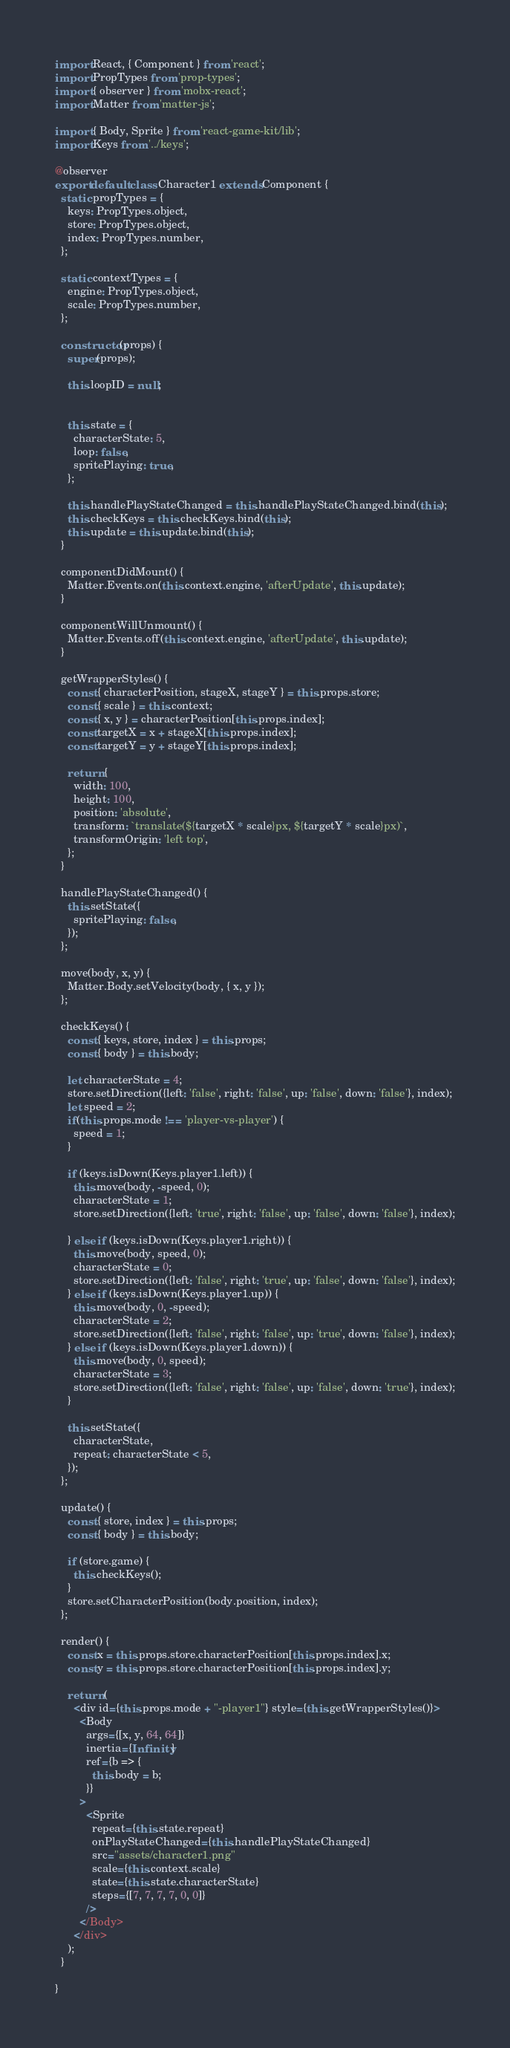Convert code to text. <code><loc_0><loc_0><loc_500><loc_500><_JavaScript_>import React, { Component } from 'react';
import PropTypes from 'prop-types';
import { observer } from 'mobx-react';
import Matter from 'matter-js';

import { Body, Sprite } from 'react-game-kit/lib';
import Keys from '../keys';

@observer
export default class Character1 extends Component {
  static propTypes = {
    keys: PropTypes.object,
    store: PropTypes.object,
    index: PropTypes.number,
  };

  static contextTypes = {
    engine: PropTypes.object,
    scale: PropTypes.number,
  };

  constructor(props) {
    super(props);

    this.loopID = null;
    
    
    this.state = {
      characterState: 5,
      loop: false,
      spritePlaying: true,
    };

    this.handlePlayStateChanged = this.handlePlayStateChanged.bind(this);
    this.checkKeys = this.checkKeys.bind(this);
    this.update = this.update.bind(this);
  }

  componentDidMount() {
    Matter.Events.on(this.context.engine, 'afterUpdate', this.update);
  }

  componentWillUnmount() {
    Matter.Events.off(this.context.engine, 'afterUpdate', this.update);
  }

  getWrapperStyles() {
    const { characterPosition, stageX, stageY } = this.props.store;
    const { scale } = this.context;
    const { x, y } = characterPosition[this.props.index];
    const targetX = x + stageX[this.props.index];
    const targetY = y + stageY[this.props.index];

    return {
      width: 100,
      height: 100,
      position: 'absolute',
      transform: `translate(${targetX * scale}px, ${targetY * scale}px)`,
      transformOrigin: 'left top',
    };
  }

  handlePlayStateChanged() {
    this.setState({
      spritePlaying: false,
    });
  };

  move(body, x, y) {
    Matter.Body.setVelocity(body, { x, y });
  };

  checkKeys() {
    const { keys, store, index } = this.props;
    const { body } = this.body;

    let characterState = 4;
    store.setDirection({left: 'false', right: 'false', up: 'false', down: 'false'}, index);
    let speed = 2;
    if(this.props.mode !== 'player-vs-player') {
      speed = 1;
    }

    if (keys.isDown(Keys.player1.left)) {
      this.move(body, -speed, 0);
      characterState = 1;
      store.setDirection({left: 'true', right: 'false', up: 'false', down: 'false'}, index);

    } else if (keys.isDown(Keys.player1.right)) {
      this.move(body, speed, 0);
      characterState = 0;
      store.setDirection({left: 'false', right: 'true', up: 'false', down: 'false'}, index);
    } else if (keys.isDown(Keys.player1.up)) {
      this.move(body, 0, -speed);
      characterState = 2;
      store.setDirection({left: 'false', right: 'false', up: 'true', down: 'false'}, index);
    } else if (keys.isDown(Keys.player1.down)) {
      this.move(body, 0, speed);
      characterState = 3;
      store.setDirection({left: 'false', right: 'false', up: 'false', down: 'true'}, index);
    }
 
    this.setState({
      characterState,
      repeat: characterState < 5,
    });
  };

  update() {
    const { store, index } = this.props;
    const { body } = this.body;

    if (store.game) {
      this.checkKeys();
    }
    store.setCharacterPosition(body.position, index);
  };

  render() {
    const x = this.props.store.characterPosition[this.props.index].x;
    const y = this.props.store.characterPosition[this.props.index].y;

    return (
      <div id={this.props.mode + "-player1"} style={this.getWrapperStyles()}>
        <Body
          args={[x, y, 64, 64]}
          inertia={Infinity}
          ref={b => {
            this.body = b;
          }}
        >
          <Sprite
            repeat={this.state.repeat}
            onPlayStateChanged={this.handlePlayStateChanged}
            src="assets/character1.png"
            scale={this.context.scale}
            state={this.state.characterState}
            steps={[7, 7, 7, 7, 0, 0]}
          />
        </Body>
      </div>
    );
  }
 
}
</code> 